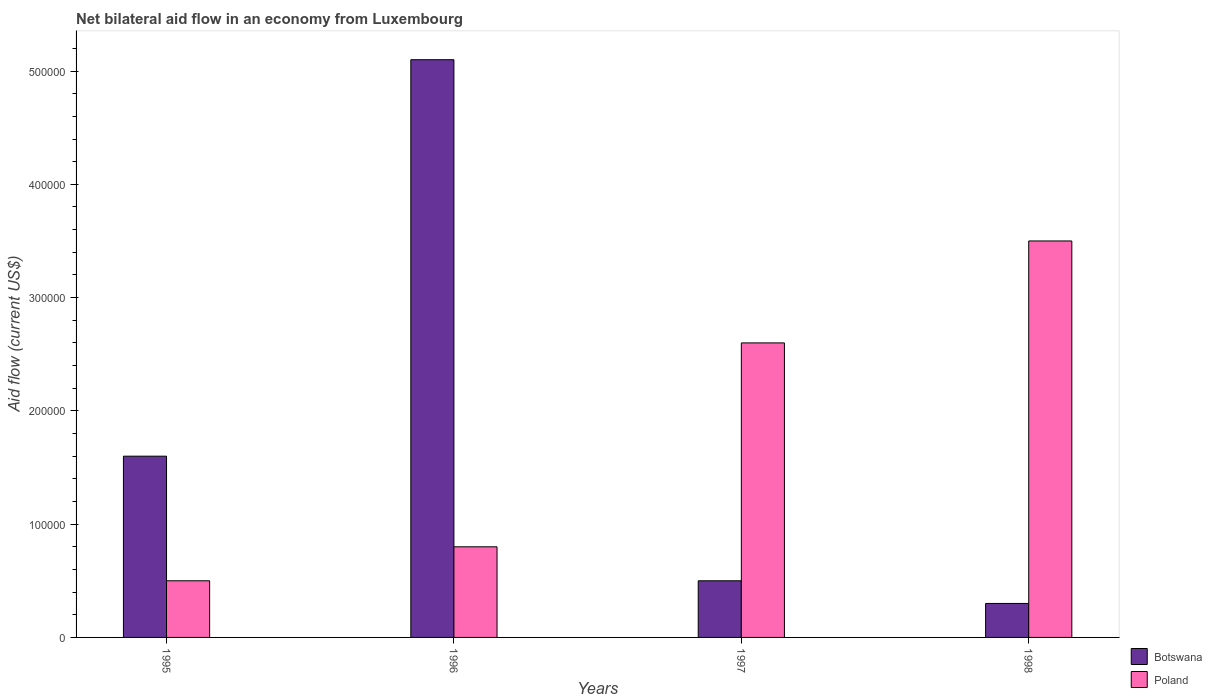How many different coloured bars are there?
Your response must be concise. 2. How many groups of bars are there?
Provide a succinct answer. 4. Are the number of bars per tick equal to the number of legend labels?
Offer a very short reply. Yes. Are the number of bars on each tick of the X-axis equal?
Ensure brevity in your answer.  Yes. How many bars are there on the 2nd tick from the left?
Ensure brevity in your answer.  2. How many bars are there on the 2nd tick from the right?
Ensure brevity in your answer.  2. What is the label of the 3rd group of bars from the left?
Your answer should be compact. 1997. What is the net bilateral aid flow in Botswana in 1998?
Provide a short and direct response. 3.00e+04. Across all years, what is the maximum net bilateral aid flow in Poland?
Offer a very short reply. 3.50e+05. In which year was the net bilateral aid flow in Poland minimum?
Ensure brevity in your answer.  1995. What is the total net bilateral aid flow in Botswana in the graph?
Your answer should be compact. 7.50e+05. What is the difference between the net bilateral aid flow in Poland in 1997 and that in 1998?
Give a very brief answer. -9.00e+04. What is the average net bilateral aid flow in Botswana per year?
Provide a short and direct response. 1.88e+05. In the year 1995, what is the difference between the net bilateral aid flow in Botswana and net bilateral aid flow in Poland?
Ensure brevity in your answer.  1.10e+05. In how many years, is the net bilateral aid flow in Poland greater than 20000 US$?
Offer a terse response. 4. What is the ratio of the net bilateral aid flow in Poland in 1997 to that in 1998?
Offer a terse response. 0.74. Is the difference between the net bilateral aid flow in Botswana in 1995 and 1998 greater than the difference between the net bilateral aid flow in Poland in 1995 and 1998?
Give a very brief answer. Yes. What is the difference between the highest and the second highest net bilateral aid flow in Poland?
Keep it short and to the point. 9.00e+04. What is the difference between the highest and the lowest net bilateral aid flow in Poland?
Your answer should be very brief. 3.00e+05. Is the sum of the net bilateral aid flow in Poland in 1996 and 1997 greater than the maximum net bilateral aid flow in Botswana across all years?
Provide a short and direct response. No. What does the 2nd bar from the right in 1998 represents?
Ensure brevity in your answer.  Botswana. Are all the bars in the graph horizontal?
Offer a very short reply. No. What is the difference between two consecutive major ticks on the Y-axis?
Give a very brief answer. 1.00e+05. Are the values on the major ticks of Y-axis written in scientific E-notation?
Provide a succinct answer. No. Does the graph contain grids?
Ensure brevity in your answer.  No. Where does the legend appear in the graph?
Offer a terse response. Bottom right. What is the title of the graph?
Your answer should be very brief. Net bilateral aid flow in an economy from Luxembourg. Does "Lower middle income" appear as one of the legend labels in the graph?
Your answer should be compact. No. What is the label or title of the X-axis?
Ensure brevity in your answer.  Years. What is the Aid flow (current US$) in Botswana in 1995?
Your answer should be very brief. 1.60e+05. What is the Aid flow (current US$) in Botswana in 1996?
Provide a short and direct response. 5.10e+05. What is the Aid flow (current US$) of Botswana in 1997?
Offer a very short reply. 5.00e+04. What is the Aid flow (current US$) in Poland in 1998?
Your answer should be very brief. 3.50e+05. Across all years, what is the maximum Aid flow (current US$) of Botswana?
Your answer should be very brief. 5.10e+05. Across all years, what is the maximum Aid flow (current US$) of Poland?
Your answer should be compact. 3.50e+05. Across all years, what is the minimum Aid flow (current US$) of Poland?
Make the answer very short. 5.00e+04. What is the total Aid flow (current US$) in Botswana in the graph?
Keep it short and to the point. 7.50e+05. What is the total Aid flow (current US$) in Poland in the graph?
Provide a succinct answer. 7.40e+05. What is the difference between the Aid flow (current US$) in Botswana in 1995 and that in 1996?
Offer a terse response. -3.50e+05. What is the difference between the Aid flow (current US$) in Poland in 1995 and that in 1996?
Your response must be concise. -3.00e+04. What is the difference between the Aid flow (current US$) of Botswana in 1995 and that in 1997?
Give a very brief answer. 1.10e+05. What is the difference between the Aid flow (current US$) in Poland in 1995 and that in 1997?
Provide a succinct answer. -2.10e+05. What is the difference between the Aid flow (current US$) in Botswana in 1995 and that in 1998?
Your response must be concise. 1.30e+05. What is the difference between the Aid flow (current US$) in Poland in 1995 and that in 1998?
Ensure brevity in your answer.  -3.00e+05. What is the difference between the Aid flow (current US$) of Botswana in 1996 and that in 1998?
Your answer should be very brief. 4.80e+05. What is the difference between the Aid flow (current US$) of Poland in 1997 and that in 1998?
Make the answer very short. -9.00e+04. What is the difference between the Aid flow (current US$) in Botswana in 1995 and the Aid flow (current US$) in Poland in 1996?
Provide a short and direct response. 8.00e+04. What is the difference between the Aid flow (current US$) in Botswana in 1995 and the Aid flow (current US$) in Poland in 1997?
Provide a succinct answer. -1.00e+05. What is the difference between the Aid flow (current US$) in Botswana in 1995 and the Aid flow (current US$) in Poland in 1998?
Provide a short and direct response. -1.90e+05. What is the difference between the Aid flow (current US$) in Botswana in 1996 and the Aid flow (current US$) in Poland in 1997?
Ensure brevity in your answer.  2.50e+05. What is the difference between the Aid flow (current US$) in Botswana in 1996 and the Aid flow (current US$) in Poland in 1998?
Provide a short and direct response. 1.60e+05. What is the difference between the Aid flow (current US$) of Botswana in 1997 and the Aid flow (current US$) of Poland in 1998?
Ensure brevity in your answer.  -3.00e+05. What is the average Aid flow (current US$) in Botswana per year?
Make the answer very short. 1.88e+05. What is the average Aid flow (current US$) in Poland per year?
Offer a very short reply. 1.85e+05. In the year 1997, what is the difference between the Aid flow (current US$) of Botswana and Aid flow (current US$) of Poland?
Your response must be concise. -2.10e+05. In the year 1998, what is the difference between the Aid flow (current US$) in Botswana and Aid flow (current US$) in Poland?
Your answer should be compact. -3.20e+05. What is the ratio of the Aid flow (current US$) in Botswana in 1995 to that in 1996?
Offer a very short reply. 0.31. What is the ratio of the Aid flow (current US$) of Poland in 1995 to that in 1996?
Provide a succinct answer. 0.62. What is the ratio of the Aid flow (current US$) of Botswana in 1995 to that in 1997?
Give a very brief answer. 3.2. What is the ratio of the Aid flow (current US$) of Poland in 1995 to that in 1997?
Offer a terse response. 0.19. What is the ratio of the Aid flow (current US$) of Botswana in 1995 to that in 1998?
Your answer should be very brief. 5.33. What is the ratio of the Aid flow (current US$) of Poland in 1995 to that in 1998?
Keep it short and to the point. 0.14. What is the ratio of the Aid flow (current US$) in Botswana in 1996 to that in 1997?
Make the answer very short. 10.2. What is the ratio of the Aid flow (current US$) of Poland in 1996 to that in 1997?
Ensure brevity in your answer.  0.31. What is the ratio of the Aid flow (current US$) in Botswana in 1996 to that in 1998?
Ensure brevity in your answer.  17. What is the ratio of the Aid flow (current US$) in Poland in 1996 to that in 1998?
Offer a terse response. 0.23. What is the ratio of the Aid flow (current US$) of Botswana in 1997 to that in 1998?
Make the answer very short. 1.67. What is the ratio of the Aid flow (current US$) in Poland in 1997 to that in 1998?
Offer a terse response. 0.74. What is the difference between the highest and the lowest Aid flow (current US$) in Poland?
Your answer should be very brief. 3.00e+05. 